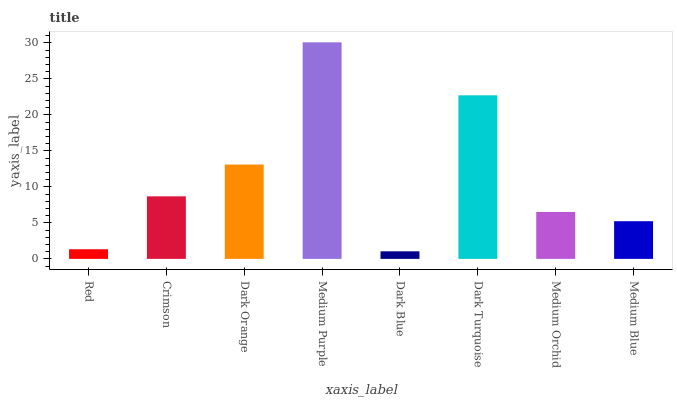Is Dark Blue the minimum?
Answer yes or no. Yes. Is Medium Purple the maximum?
Answer yes or no. Yes. Is Crimson the minimum?
Answer yes or no. No. Is Crimson the maximum?
Answer yes or no. No. Is Crimson greater than Red?
Answer yes or no. Yes. Is Red less than Crimson?
Answer yes or no. Yes. Is Red greater than Crimson?
Answer yes or no. No. Is Crimson less than Red?
Answer yes or no. No. Is Crimson the high median?
Answer yes or no. Yes. Is Medium Orchid the low median?
Answer yes or no. Yes. Is Dark Orange the high median?
Answer yes or no. No. Is Medium Purple the low median?
Answer yes or no. No. 